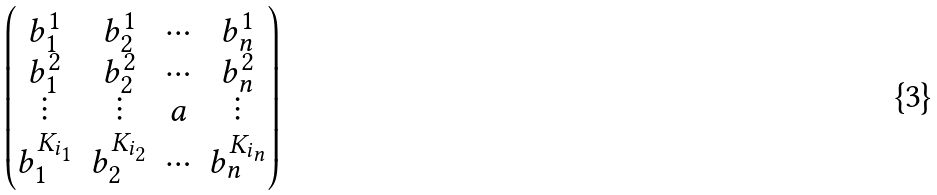<formula> <loc_0><loc_0><loc_500><loc_500>\begin{pmatrix} b _ { 1 } ^ { 1 } & b _ { 2 } ^ { 1 } & \cdots & b _ { n } ^ { 1 } \\ b _ { 1 } ^ { 2 } & b _ { 2 } ^ { 2 } & \cdots & b _ { n } ^ { 2 } \\ \vdots & \vdots & a & \vdots \\ b _ { 1 } ^ { K _ { i _ { 1 } } } & b _ { 2 } ^ { K _ { i _ { 2 } } } & \cdots & b _ { n } ^ { K _ { i _ { n } } } \end{pmatrix}</formula> 